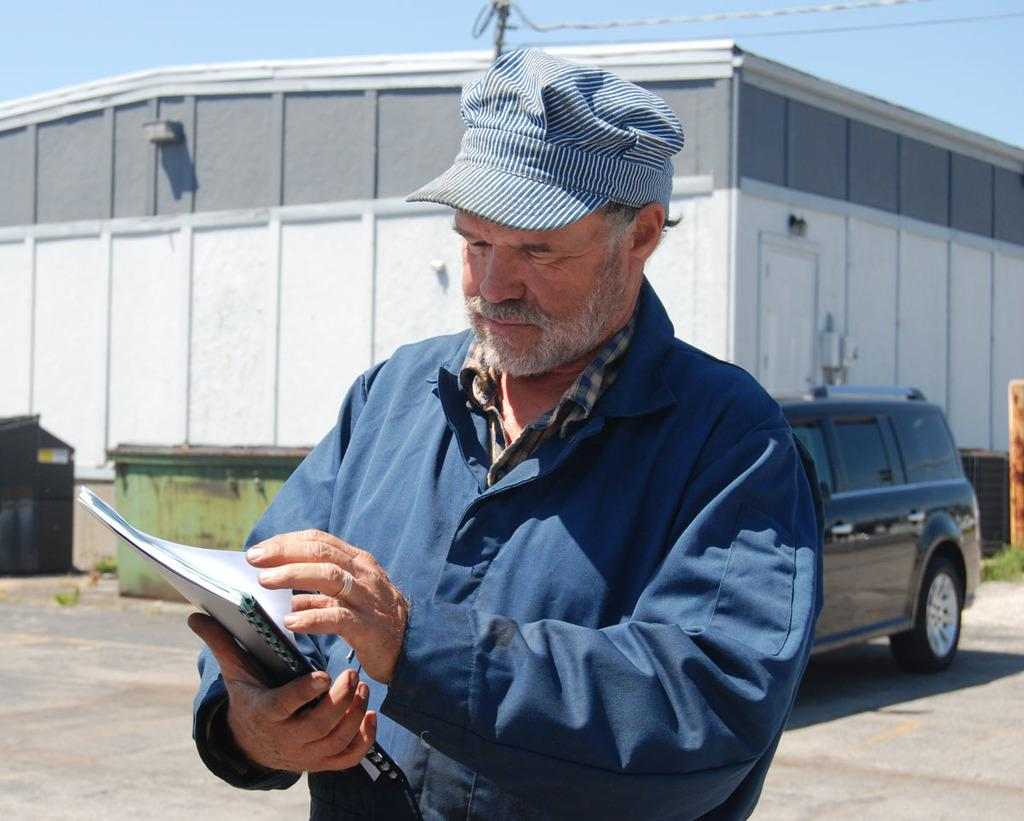What is the person in the image holding? The person is holding a book in the image. What can be seen behind the person? There is a vehicle, a shed, and containers behind the person. What is visible at the top of the image? The sky is visible at the top of the image, along with wires. What reason does the person have for jumping on the tramp in the image? There is no tramp present in the image, so the person cannot be seen jumping on one. 